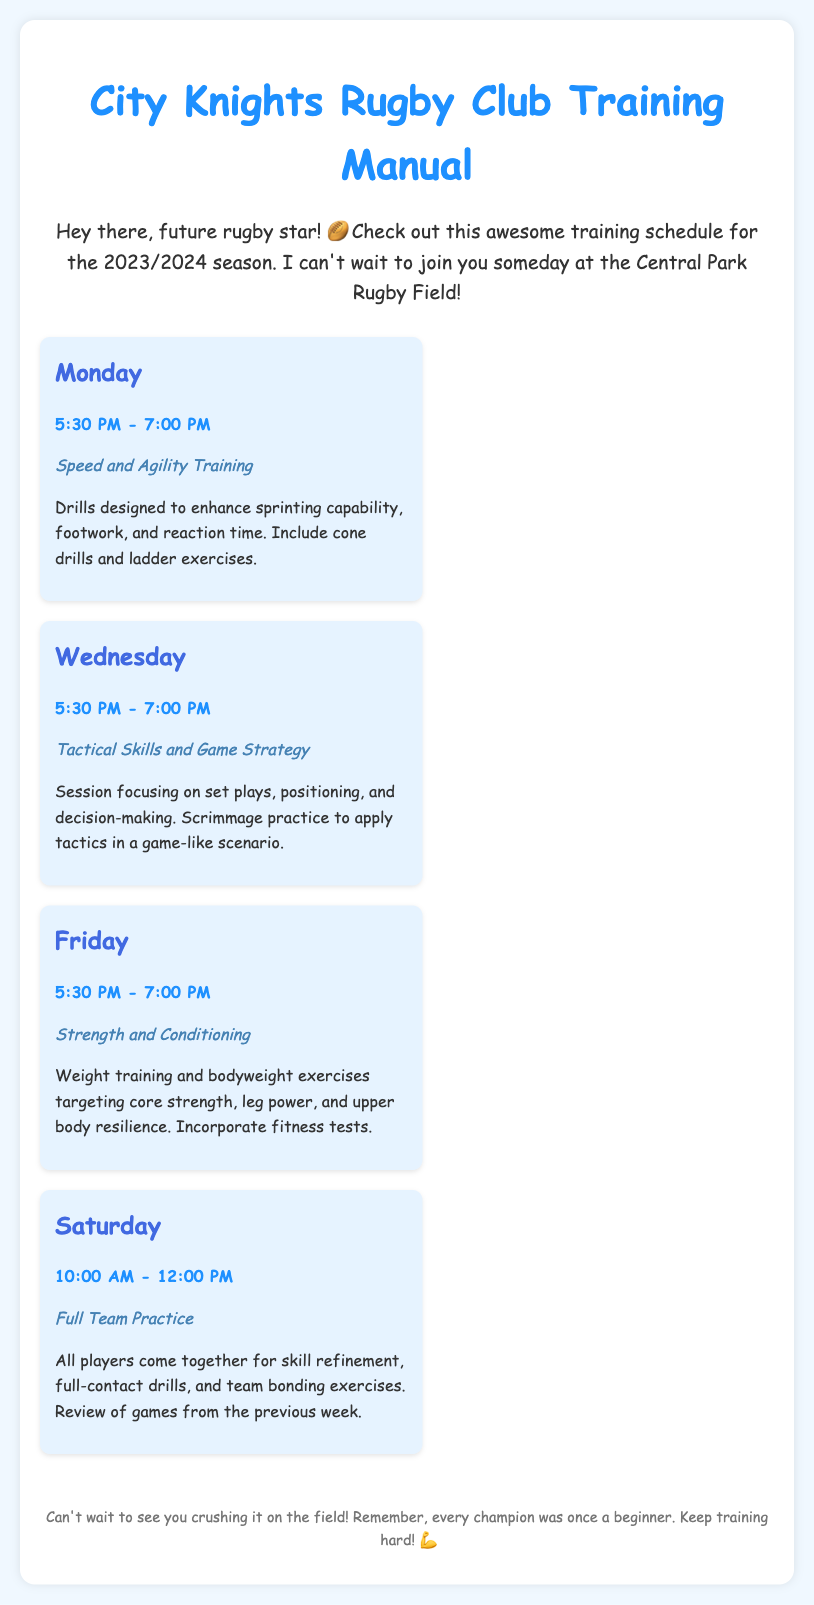What day is Speed and Agility Training? The document states that Speed and Agility Training is scheduled for Monday.
Answer: Monday What time does Full Team Practice start? The starting time for Full Team Practice as per the document is 10:00 AM.
Answer: 10:00 AM What is the focus of the Wednesday session? The Wednesday session focuses on Tactical Skills and Game Strategy, as mentioned in the document.
Answer: Tactical Skills and Game Strategy How long is each training session? Each training session is scheduled for 1.5 hours, as can be inferred from the time slots provided.
Answer: 1.5 hours What type of exercises are included in the Friday session? The Friday session includes weight training and bodyweight exercises targeted for strength and conditioning.
Answer: Weight training and bodyweight exercises What is emphasized during the Saturday practice? The Saturday practice emphasizes skill refinement and team bonding exercises.
Answer: Skill refinement and team bonding exercises What is the overarching theme of the introduction? The introduction encourages future players and expresses excitement about joining the club.
Answer: Encouragement and excitement What is the location for the training sessions? The document mentions that the training sessions take place at Central Park Rugby Field.
Answer: Central Park Rugby Field 